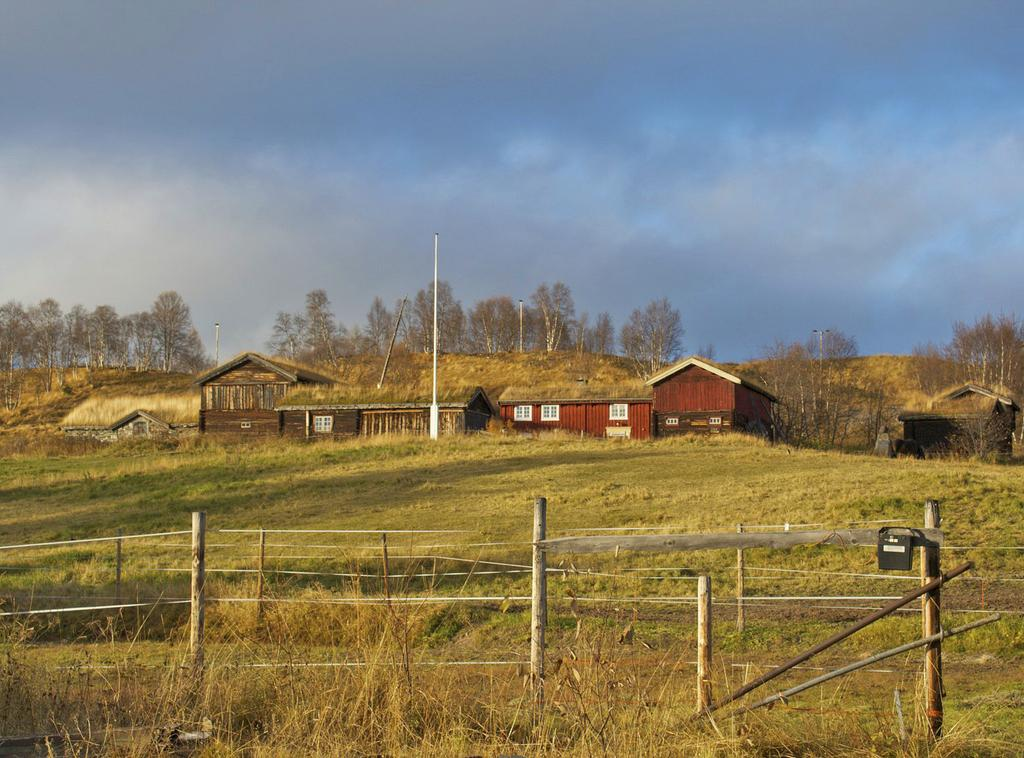What type of barrier can be seen in the image? There is a fence in the image. What type of vegetation is present in the image? There is grass in the image. What can be seen in the distance in the image? There are houses, trees, and poles in the background of the image. How many balls are visible in the image? There are no balls present in the image. What day of the week is depicted in the image? The image does not depict a specific day of the week. 